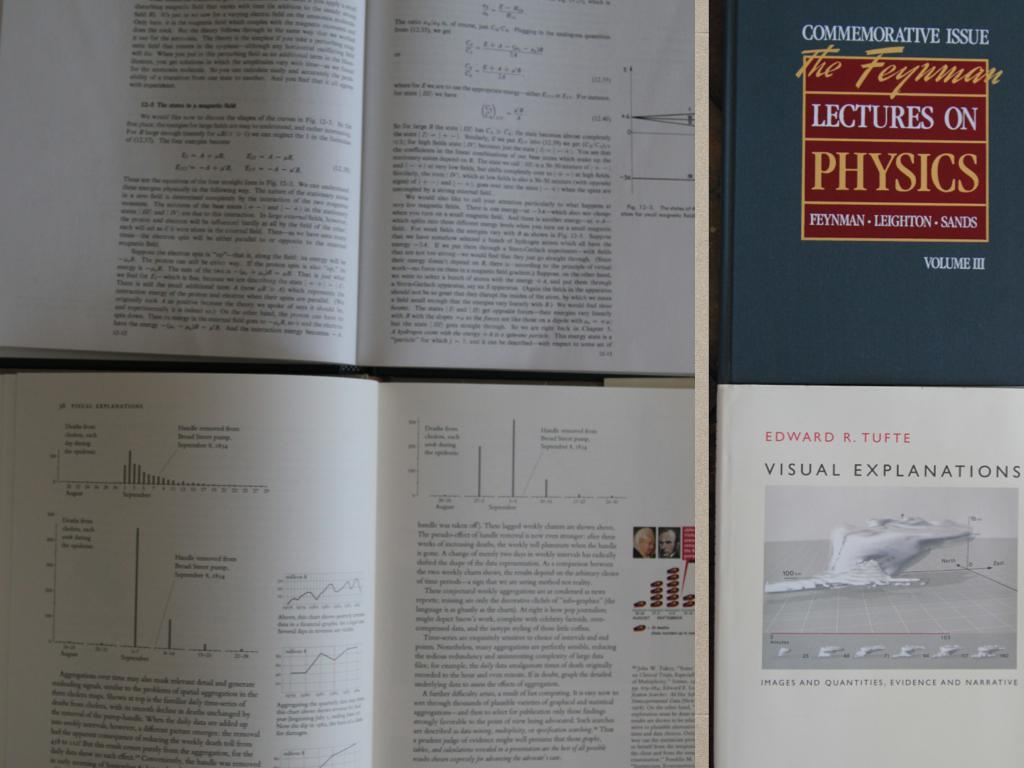<image>
Provide a brief description of the given image. Multiple pages of a book are on display, one of the books on display is titled Lectures on Physics. 